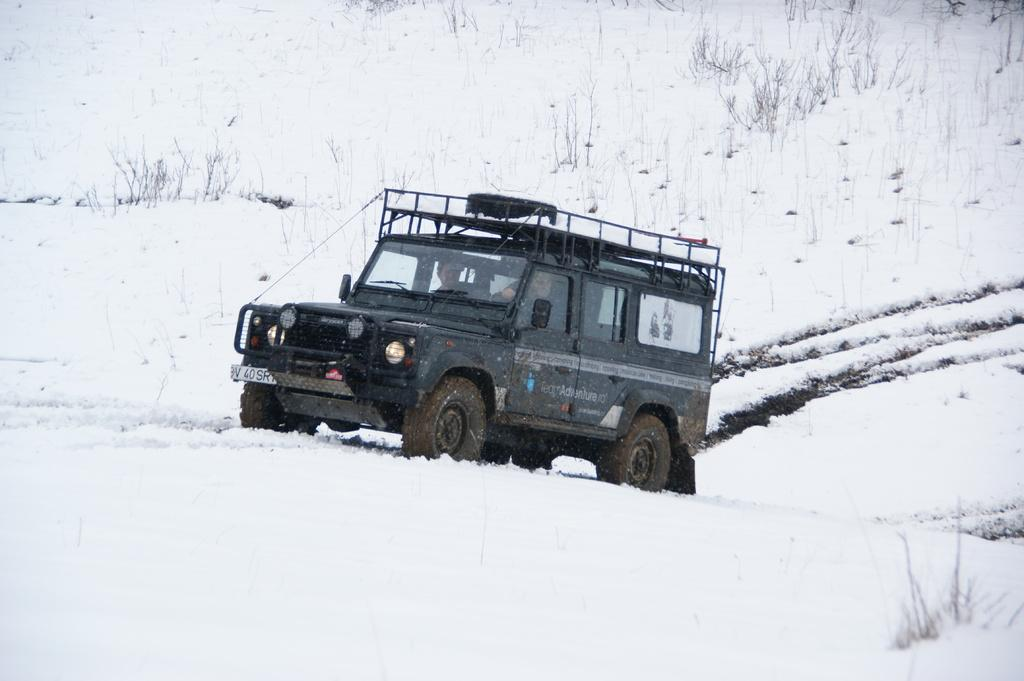What is the main subject in the foreground of the image? There is a jeep in the foreground of the image. What is the terrain like where the jeep is located? The jeep is on the snow. What can be seen in the background of the image? There are plants in the background of the image. Are the plants also on the snow? Yes, the plants are on the snow. What type of unit is being discussed in the statement made by the jeep in the image? There is no statement made by the jeep in the image, and therefore no unit is being discussed. 